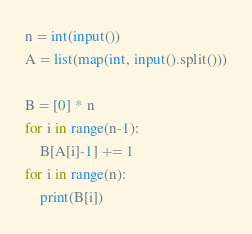Convert code to text. <code><loc_0><loc_0><loc_500><loc_500><_Python_>n = int(input())
A = list(map(int, input().split()))

B = [0] * n
for i in range(n-1):
    B[A[i]-1] += 1
for i in range(n):
    print(B[i])</code> 